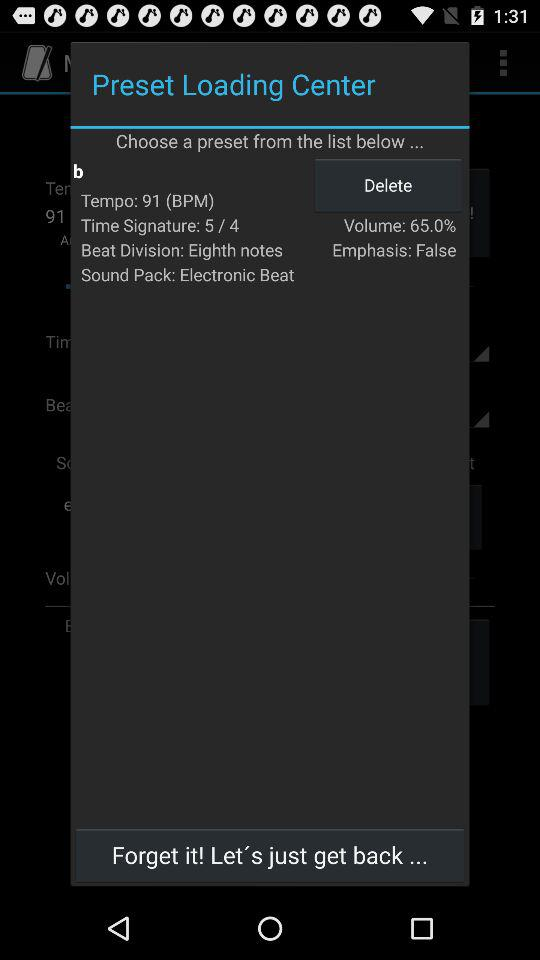What is the percentage of the volume? The percentage of the volume is 65.0. 